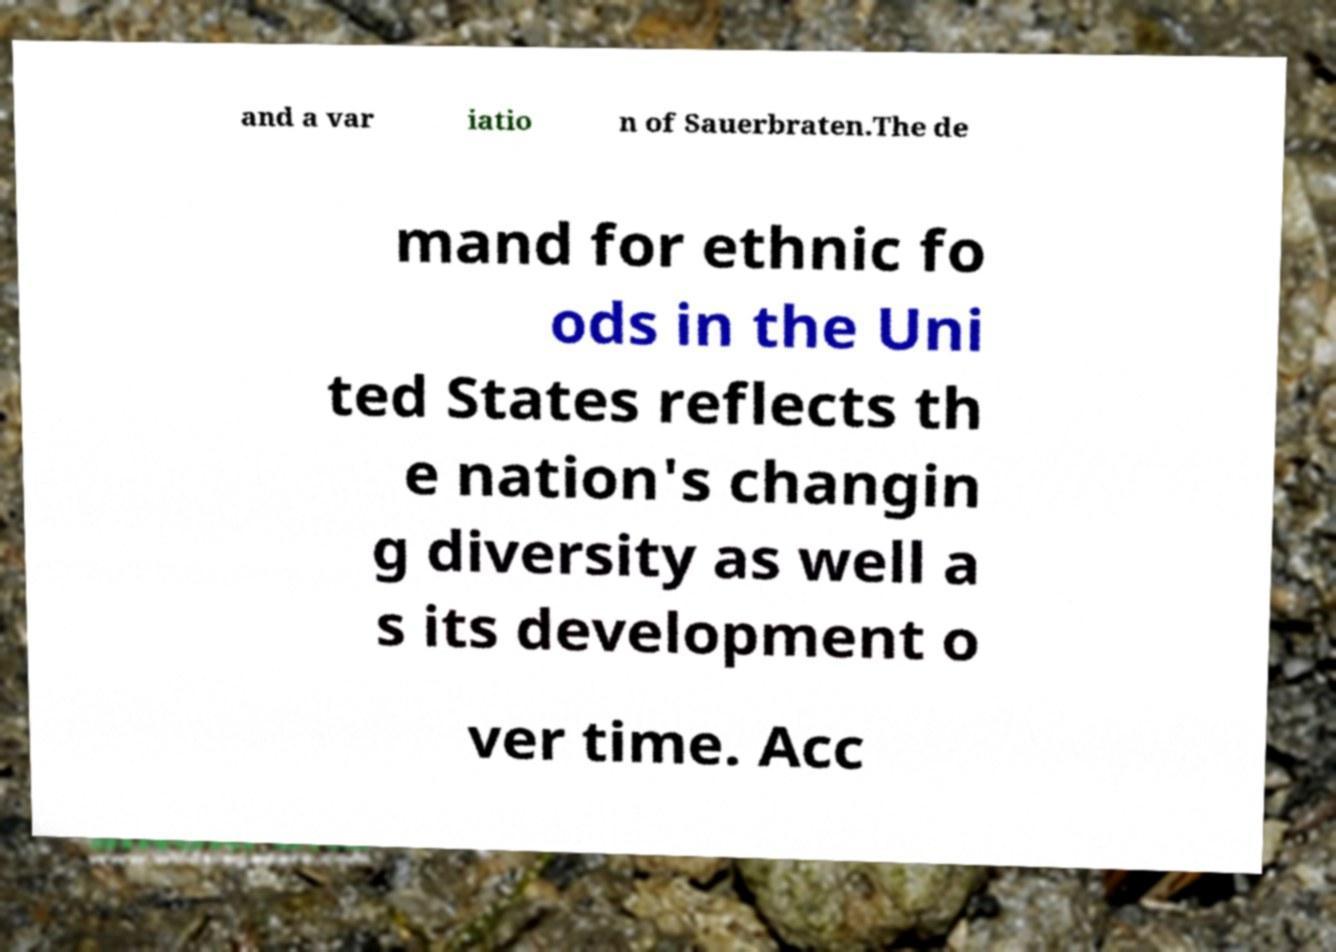I need the written content from this picture converted into text. Can you do that? and a var iatio n of Sauerbraten.The de mand for ethnic fo ods in the Uni ted States reflects th e nation's changin g diversity as well a s its development o ver time. Acc 